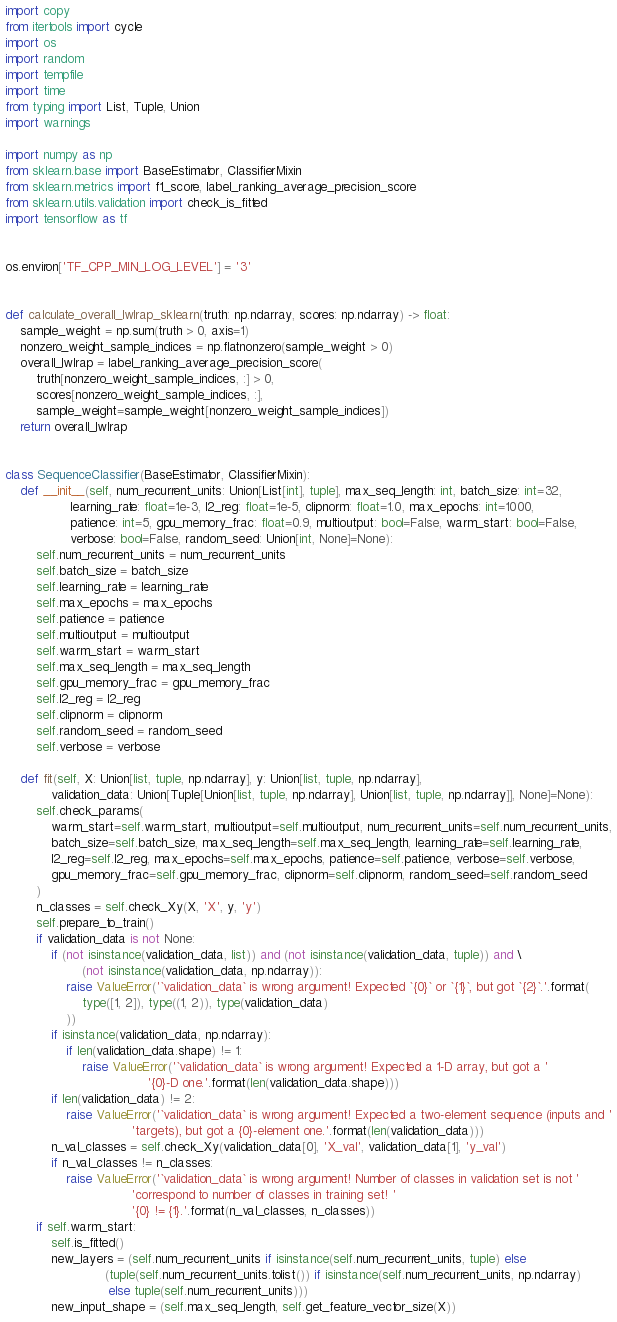<code> <loc_0><loc_0><loc_500><loc_500><_Python_>import copy
from itertools import cycle
import os
import random
import tempfile
import time
from typing import List, Tuple, Union
import warnings

import numpy as np
from sklearn.base import BaseEstimator, ClassifierMixin
from sklearn.metrics import f1_score, label_ranking_average_precision_score
from sklearn.utils.validation import check_is_fitted
import tensorflow as tf


os.environ['TF_CPP_MIN_LOG_LEVEL'] = '3'


def calculate_overall_lwlrap_sklearn(truth: np.ndarray, scores: np.ndarray) -> float:
    sample_weight = np.sum(truth > 0, axis=1)
    nonzero_weight_sample_indices = np.flatnonzero(sample_weight > 0)
    overall_lwlrap = label_ranking_average_precision_score(
        truth[nonzero_weight_sample_indices, :] > 0,
        scores[nonzero_weight_sample_indices, :],
        sample_weight=sample_weight[nonzero_weight_sample_indices])
    return overall_lwlrap


class SequenceClassifier(BaseEstimator, ClassifierMixin):
    def __init__(self, num_recurrent_units: Union[List[int], tuple], max_seq_length: int, batch_size: int=32,
                 learning_rate: float=1e-3, l2_reg: float=1e-5, clipnorm: float=1.0, max_epochs: int=1000,
                 patience: int=5, gpu_memory_frac: float=0.9, multioutput: bool=False, warm_start: bool=False,
                 verbose: bool=False, random_seed: Union[int, None]=None):
        self.num_recurrent_units = num_recurrent_units
        self.batch_size = batch_size
        self.learning_rate = learning_rate
        self.max_epochs = max_epochs
        self.patience = patience
        self.multioutput = multioutput
        self.warm_start = warm_start
        self.max_seq_length = max_seq_length
        self.gpu_memory_frac = gpu_memory_frac
        self.l2_reg = l2_reg
        self.clipnorm = clipnorm
        self.random_seed = random_seed
        self.verbose = verbose

    def fit(self, X: Union[list, tuple, np.ndarray], y: Union[list, tuple, np.ndarray],
            validation_data: Union[Tuple[Union[list, tuple, np.ndarray], Union[list, tuple, np.ndarray]], None]=None):
        self.check_params(
            warm_start=self.warm_start, multioutput=self.multioutput, num_recurrent_units=self.num_recurrent_units,
            batch_size=self.batch_size, max_seq_length=self.max_seq_length, learning_rate=self.learning_rate,
            l2_reg=self.l2_reg, max_epochs=self.max_epochs, patience=self.patience, verbose=self.verbose,
            gpu_memory_frac=self.gpu_memory_frac, clipnorm=self.clipnorm, random_seed=self.random_seed
        )
        n_classes = self.check_Xy(X, 'X', y, 'y')
        self.prepare_to_train()
        if validation_data is not None:
            if (not isinstance(validation_data, list)) and (not isinstance(validation_data, tuple)) and \
                    (not isinstance(validation_data, np.ndarray)):
                raise ValueError('`validation_data` is wrong argument! Expected `{0}` or `{1}`, but got `{2}`.'.format(
                    type([1, 2]), type((1, 2)), type(validation_data)
                ))
            if isinstance(validation_data, np.ndarray):
                if len(validation_data.shape) != 1:
                    raise ValueError('`validation_data` is wrong argument! Expected a 1-D array, but got a '
                                     '{0}-D one.'.format(len(validation_data.shape)))
            if len(validation_data) != 2:
                raise ValueError('`validation_data` is wrong argument! Expected a two-element sequence (inputs and '
                                 'targets), but got a {0}-element one.'.format(len(validation_data)))
            n_val_classes = self.check_Xy(validation_data[0], 'X_val', validation_data[1], 'y_val')
            if n_val_classes != n_classes:
                raise ValueError('`validation_data` is wrong argument! Number of classes in validation set is not '
                                 'correspond to number of classes in training set! '
                                 '{0} != {1}.'.format(n_val_classes, n_classes))
        if self.warm_start:
            self.is_fitted()
            new_layers = (self.num_recurrent_units if isinstance(self.num_recurrent_units, tuple) else
                          (tuple(self.num_recurrent_units.tolist()) if isinstance(self.num_recurrent_units, np.ndarray)
                           else tuple(self.num_recurrent_units)))
            new_input_shape = (self.max_seq_length, self.get_feature_vector_size(X))</code> 